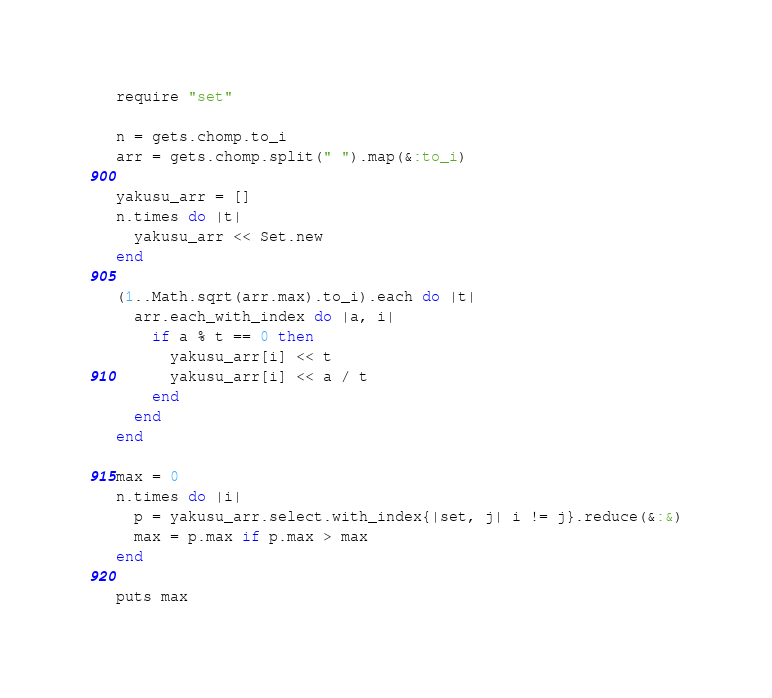Convert code to text. <code><loc_0><loc_0><loc_500><loc_500><_Ruby_>require "set"

n = gets.chomp.to_i
arr = gets.chomp.split(" ").map(&:to_i)

yakusu_arr = []
n.times do |t|
  yakusu_arr << Set.new
end

(1..Math.sqrt(arr.max).to_i).each do |t|
  arr.each_with_index do |a, i|
    if a % t == 0 then
      yakusu_arr[i] << t
      yakusu_arr[i] << a / t
    end
  end
end

max = 0
n.times do |i|
  p = yakusu_arr.select.with_index{|set, j| i != j}.reduce(&:&)
  max = p.max if p.max > max
end

puts max

</code> 